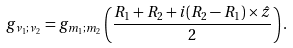<formula> <loc_0><loc_0><loc_500><loc_500>g _ { \nu _ { 1 } ; \nu _ { 2 } } = g _ { m _ { 1 } ; m _ { 2 } } \left ( \frac { { R } _ { 1 } + { R } _ { 2 } + i ( { R } _ { 2 } - { R } _ { 1 } ) \times \hat { z } } { 2 } \right ) .</formula> 